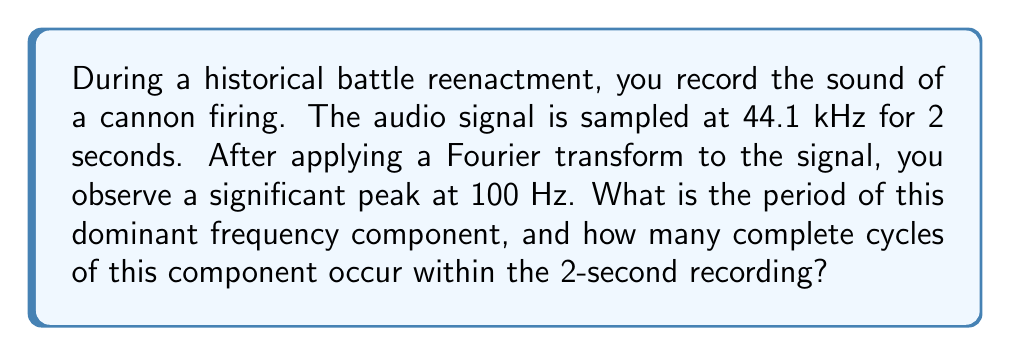Teach me how to tackle this problem. To solve this problem, we need to follow these steps:

1. Calculate the period of the dominant frequency:
   The period (T) is the inverse of the frequency (f).
   $$T = \frac{1}{f}$$
   Given f = 100 Hz,
   $$T = \frac{1}{100} = 0.01 \text{ seconds}$$

2. Calculate the number of complete cycles in the 2-second recording:
   The number of cycles (N) is equal to the total time (t) divided by the period (T).
   $$N = \frac{t}{T}$$
   Given t = 2 seconds and T = 0.01 seconds,
   $$N = \frac{2}{0.01} = 200 \text{ cycles}$$

This problem demonstrates how Fourier transform analysis can be applied to historical battle sounds. By identifying the dominant frequency components, we can gain insights into the characteristics of different weaponry and their acoustic signatures. This information can be valuable for military historians studying the impact of various weapons on battlefield dynamics and communication.
Answer: The period of the dominant frequency component is 0.01 seconds, and 200 complete cycles of this component occur within the 2-second recording. 